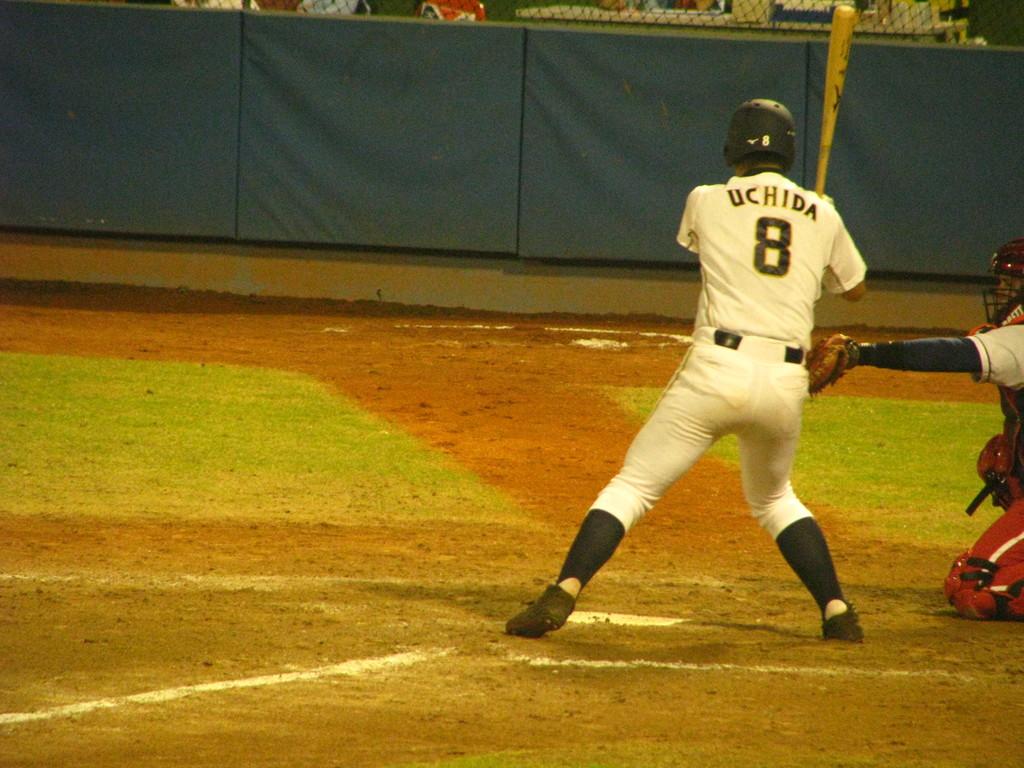What number is on the back of the baseball player's jersey?
Your response must be concise. 8. 